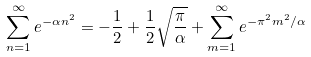<formula> <loc_0><loc_0><loc_500><loc_500>\sum _ { n = 1 } ^ { \infty } e ^ { - \alpha n ^ { 2 } } = - \frac { 1 } { 2 } + \frac { 1 } { 2 } \sqrt { \frac { \pi } { \alpha } } + \sum _ { m = 1 } ^ { \infty } e ^ { - \pi ^ { 2 } m ^ { 2 } / \alpha }</formula> 